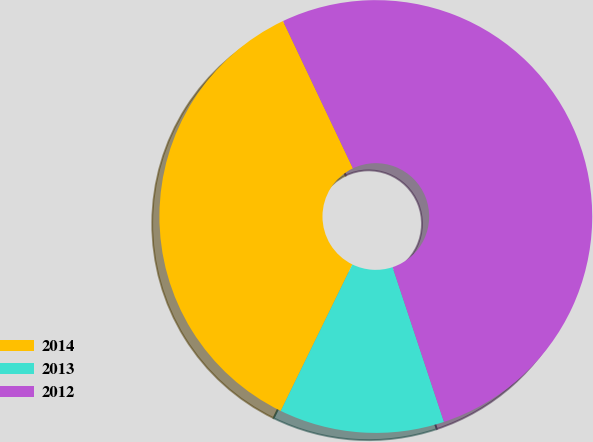Convert chart to OTSL. <chart><loc_0><loc_0><loc_500><loc_500><pie_chart><fcel>2014<fcel>2013<fcel>2012<nl><fcel>35.71%<fcel>12.34%<fcel>51.95%<nl></chart> 